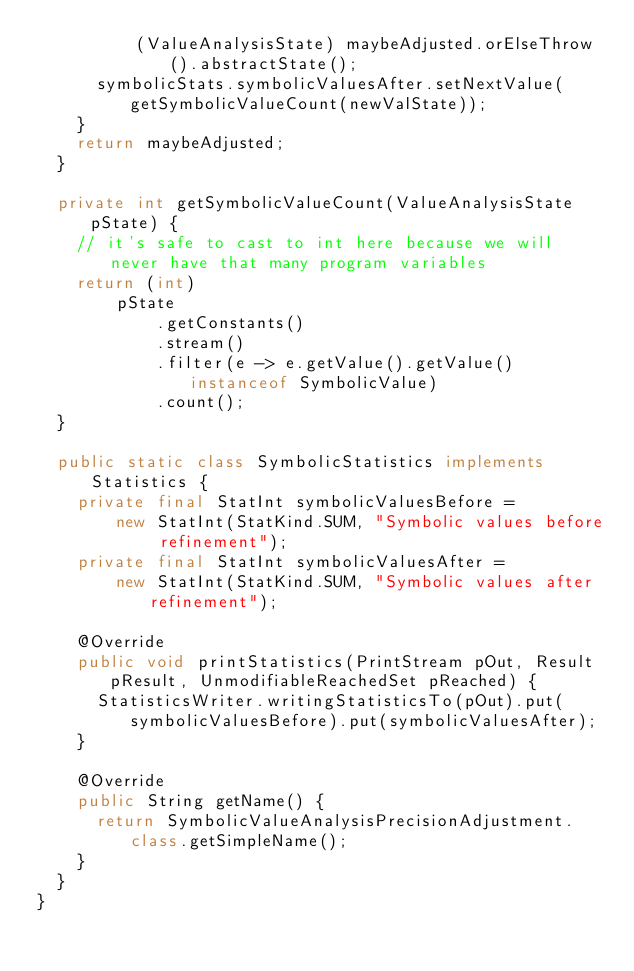<code> <loc_0><loc_0><loc_500><loc_500><_Java_>          (ValueAnalysisState) maybeAdjusted.orElseThrow().abstractState();
      symbolicStats.symbolicValuesAfter.setNextValue(getSymbolicValueCount(newValState));
    }
    return maybeAdjusted;
  }

  private int getSymbolicValueCount(ValueAnalysisState pState) {
    // it's safe to cast to int here because we will never have that many program variables
    return (int)
        pState
            .getConstants()
            .stream()
            .filter(e -> e.getValue().getValue() instanceof SymbolicValue)
            .count();
  }

  public static class SymbolicStatistics implements Statistics {
    private final StatInt symbolicValuesBefore =
        new StatInt(StatKind.SUM, "Symbolic values before refinement");
    private final StatInt symbolicValuesAfter =
        new StatInt(StatKind.SUM, "Symbolic values after refinement");

    @Override
    public void printStatistics(PrintStream pOut, Result pResult, UnmodifiableReachedSet pReached) {
      StatisticsWriter.writingStatisticsTo(pOut).put(symbolicValuesBefore).put(symbolicValuesAfter);
    }

    @Override
    public String getName() {
      return SymbolicValueAnalysisPrecisionAdjustment.class.getSimpleName();
    }
  }
}
</code> 